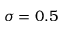<formula> <loc_0><loc_0><loc_500><loc_500>\sigma = 0 . 5</formula> 